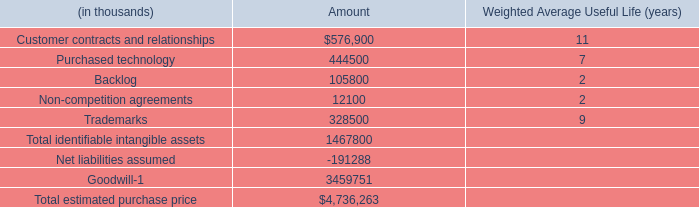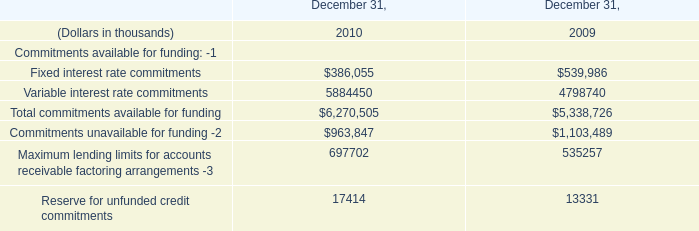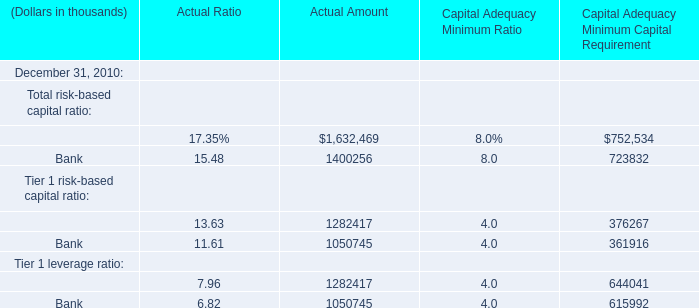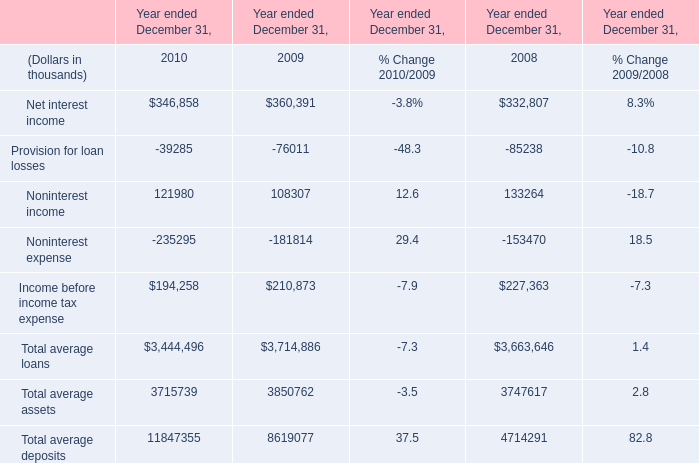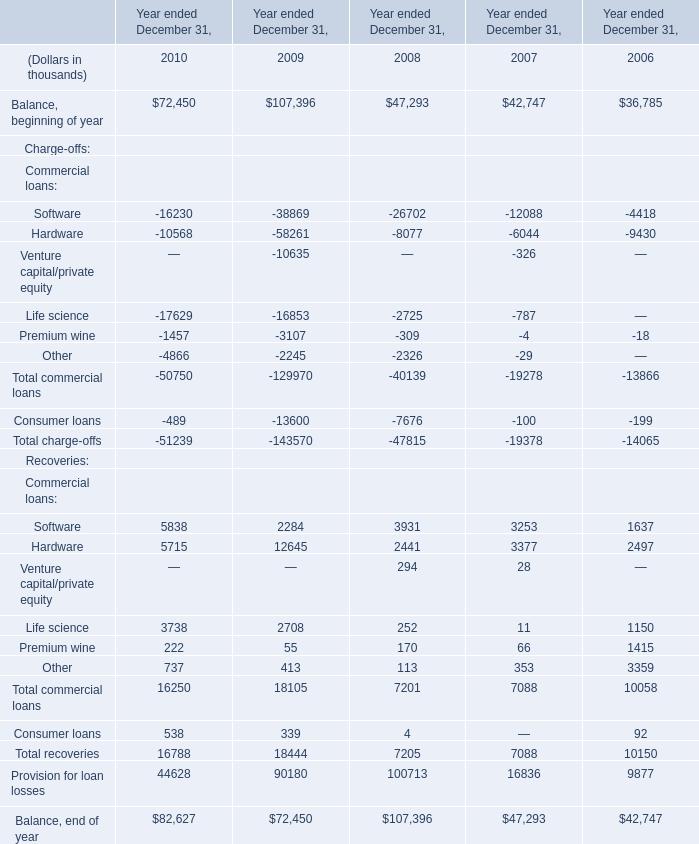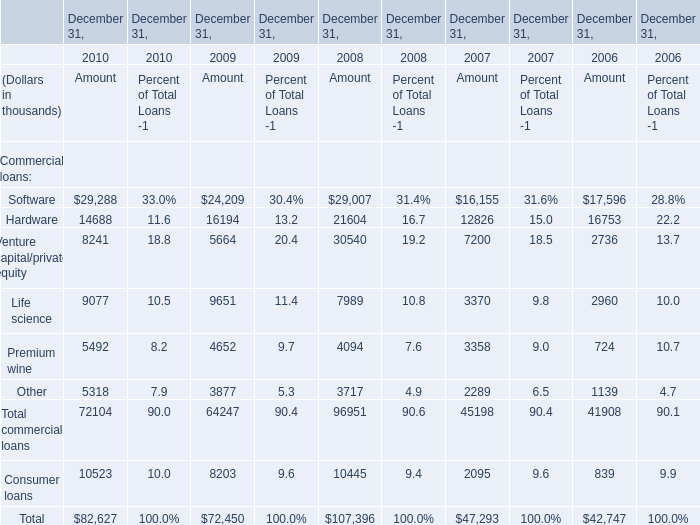What was the total amount of the Venture capital/private equity, the Total commercial loans, the Consumer loans and the Other commercial loans at December 31,2008? (in thousand) 
Computations: (((30540 + 96951) + 10445) + 3717)
Answer: 141653.0. 